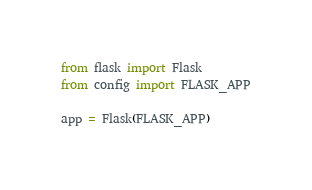Convert code to text. <code><loc_0><loc_0><loc_500><loc_500><_Python_>from flask import Flask
from config import FLASK_APP

app = Flask(FLASK_APP)</code> 